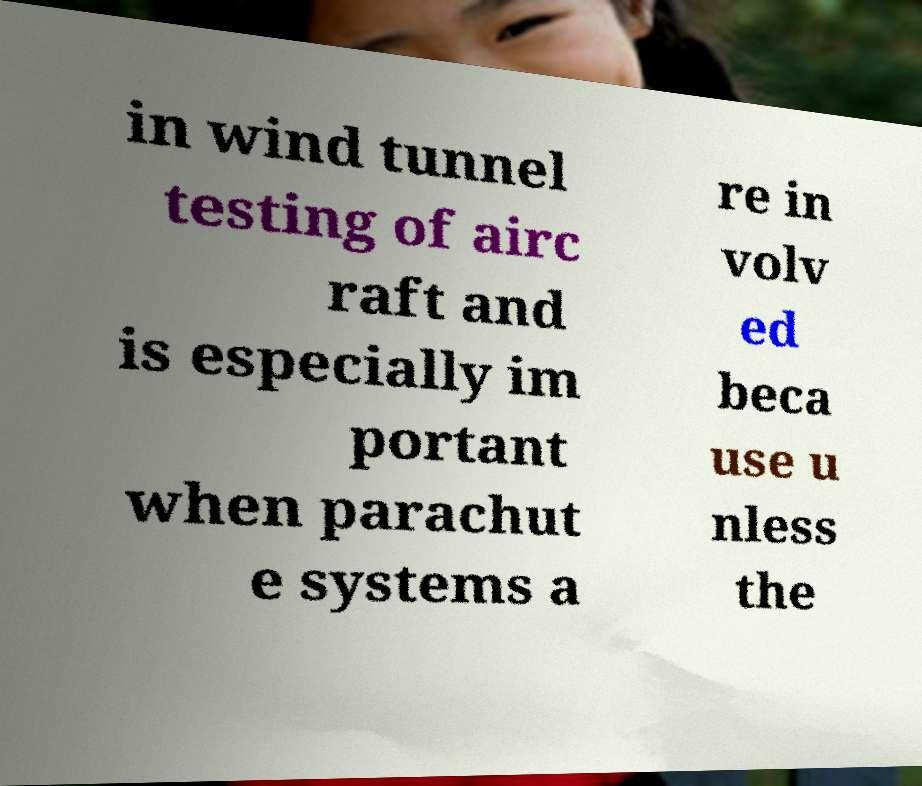There's text embedded in this image that I need extracted. Can you transcribe it verbatim? in wind tunnel testing of airc raft and is especially im portant when parachut e systems a re in volv ed beca use u nless the 